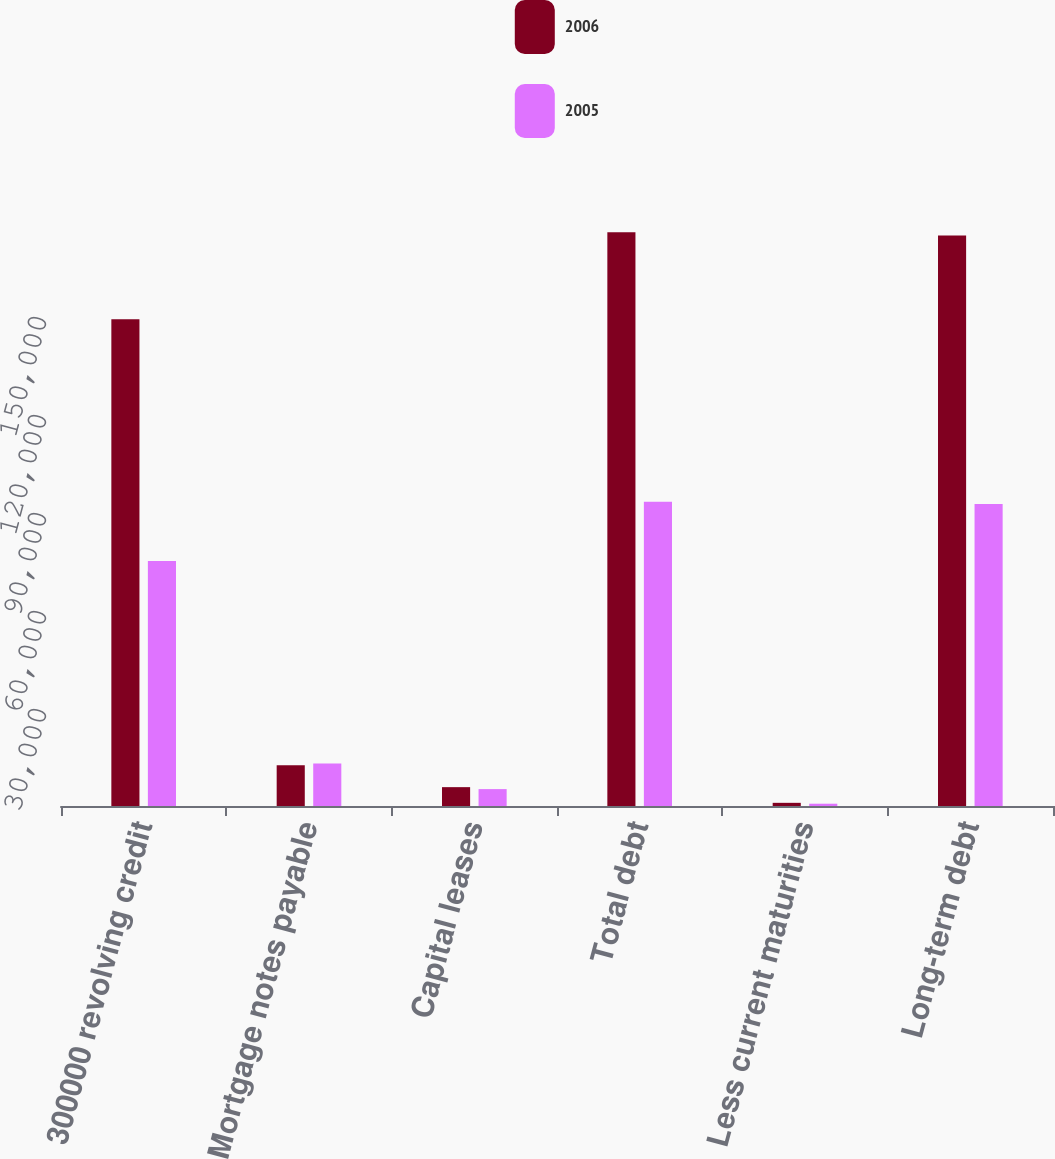Convert chart to OTSL. <chart><loc_0><loc_0><loc_500><loc_500><stacked_bar_chart><ecel><fcel>300000 revolving credit<fcel>Mortgage notes payable<fcel>Capital leases<fcel>Total debt<fcel>Less current maturities<fcel>Long-term debt<nl><fcel>2006<fcel>149000<fcel>12487<fcel>5771<fcel>175617<fcel>971<fcel>174646<nl><fcel>2005<fcel>75000<fcel>12974<fcel>5173<fcel>93147<fcel>699<fcel>92448<nl></chart> 